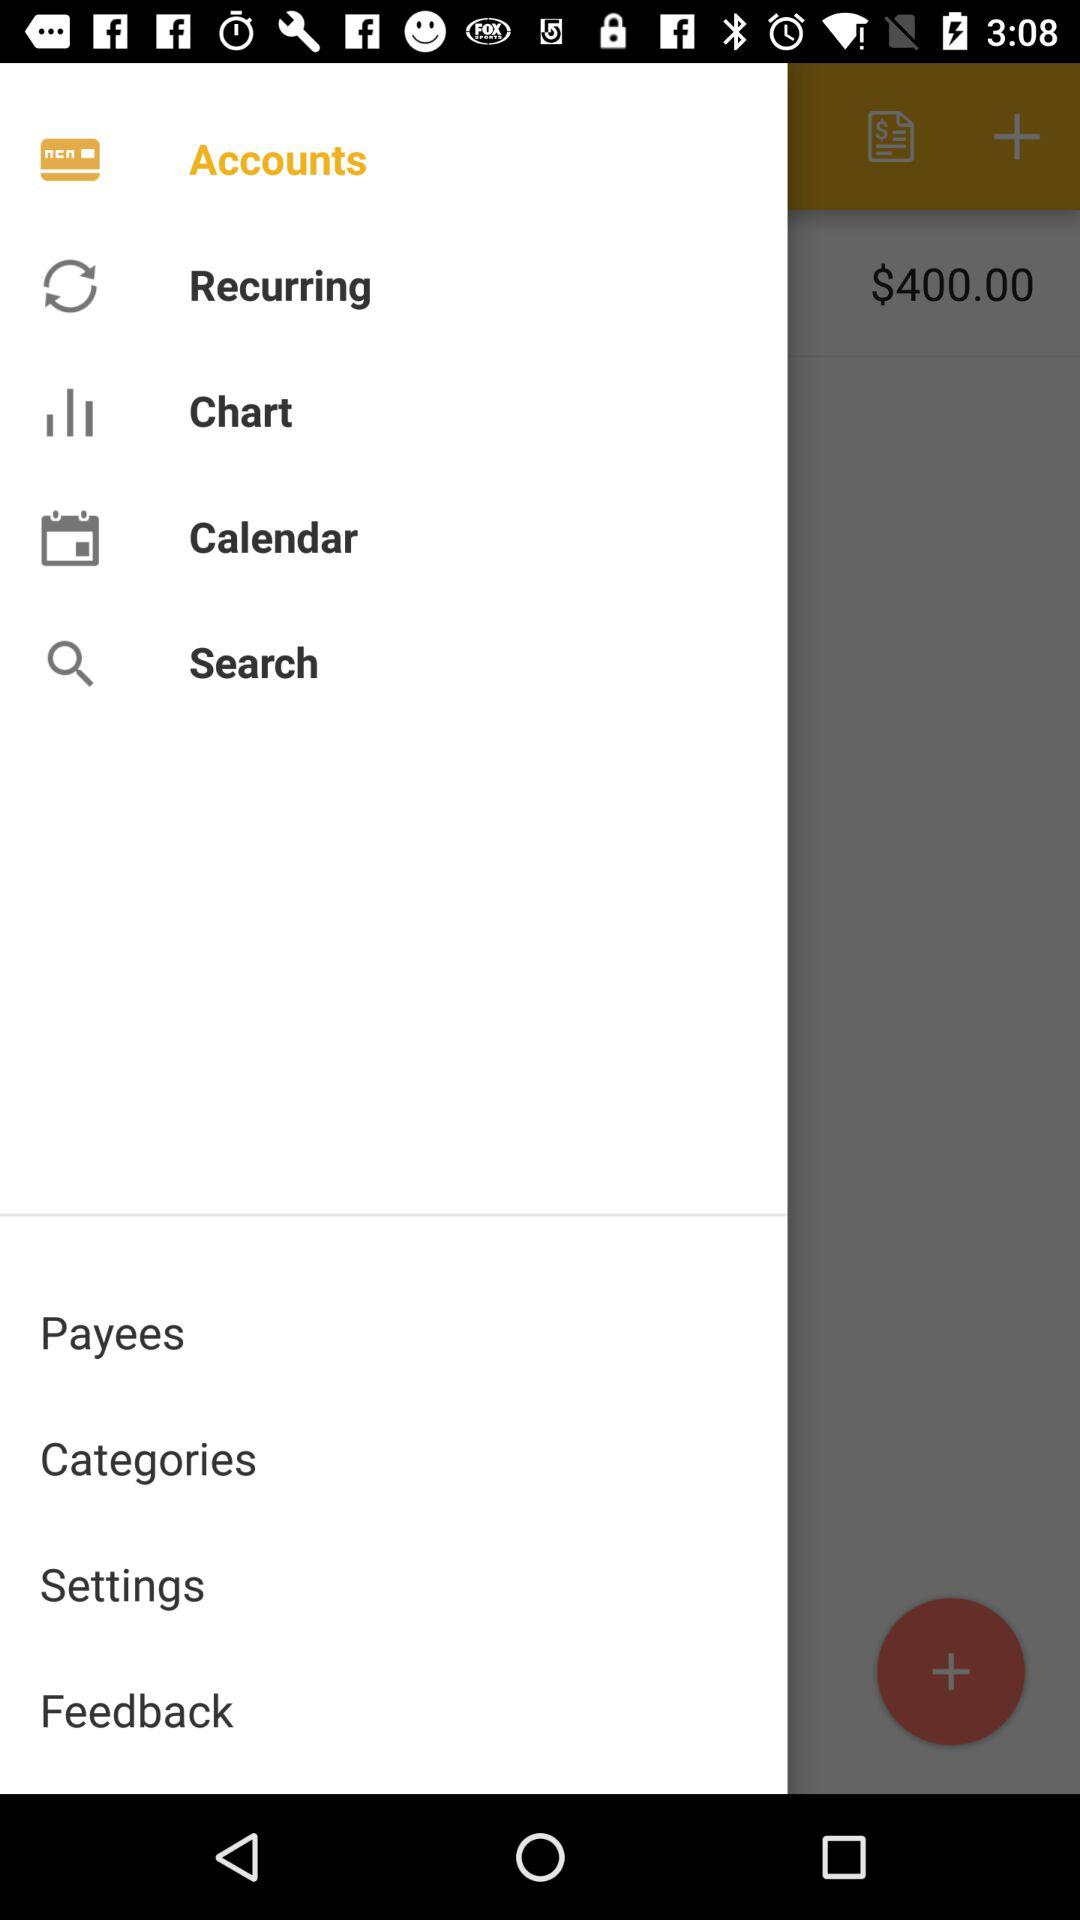How much money is in my account? $400.00 